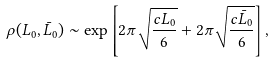Convert formula to latex. <formula><loc_0><loc_0><loc_500><loc_500>\rho ( L _ { 0 } , \bar { L } _ { 0 } ) \sim \exp \left [ 2 \pi \sqrt { \frac { c L _ { 0 } } { 6 } } + 2 \pi \sqrt { \frac { c \bar { L } _ { 0 } } { 6 } } \right ] ,</formula> 